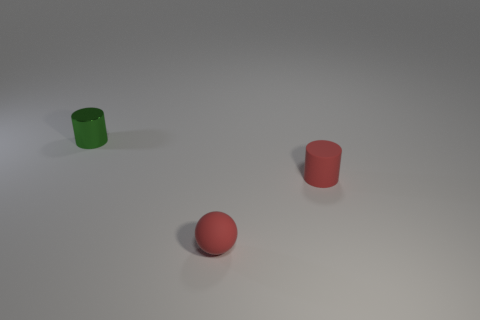Add 2 tiny red things. How many objects exist? 5 Subtract all balls. How many objects are left? 2 Add 3 large brown metal blocks. How many large brown metal blocks exist? 3 Subtract 0 yellow blocks. How many objects are left? 3 Subtract all tiny yellow metallic blocks. Subtract all tiny red things. How many objects are left? 1 Add 1 tiny red rubber things. How many tiny red rubber things are left? 3 